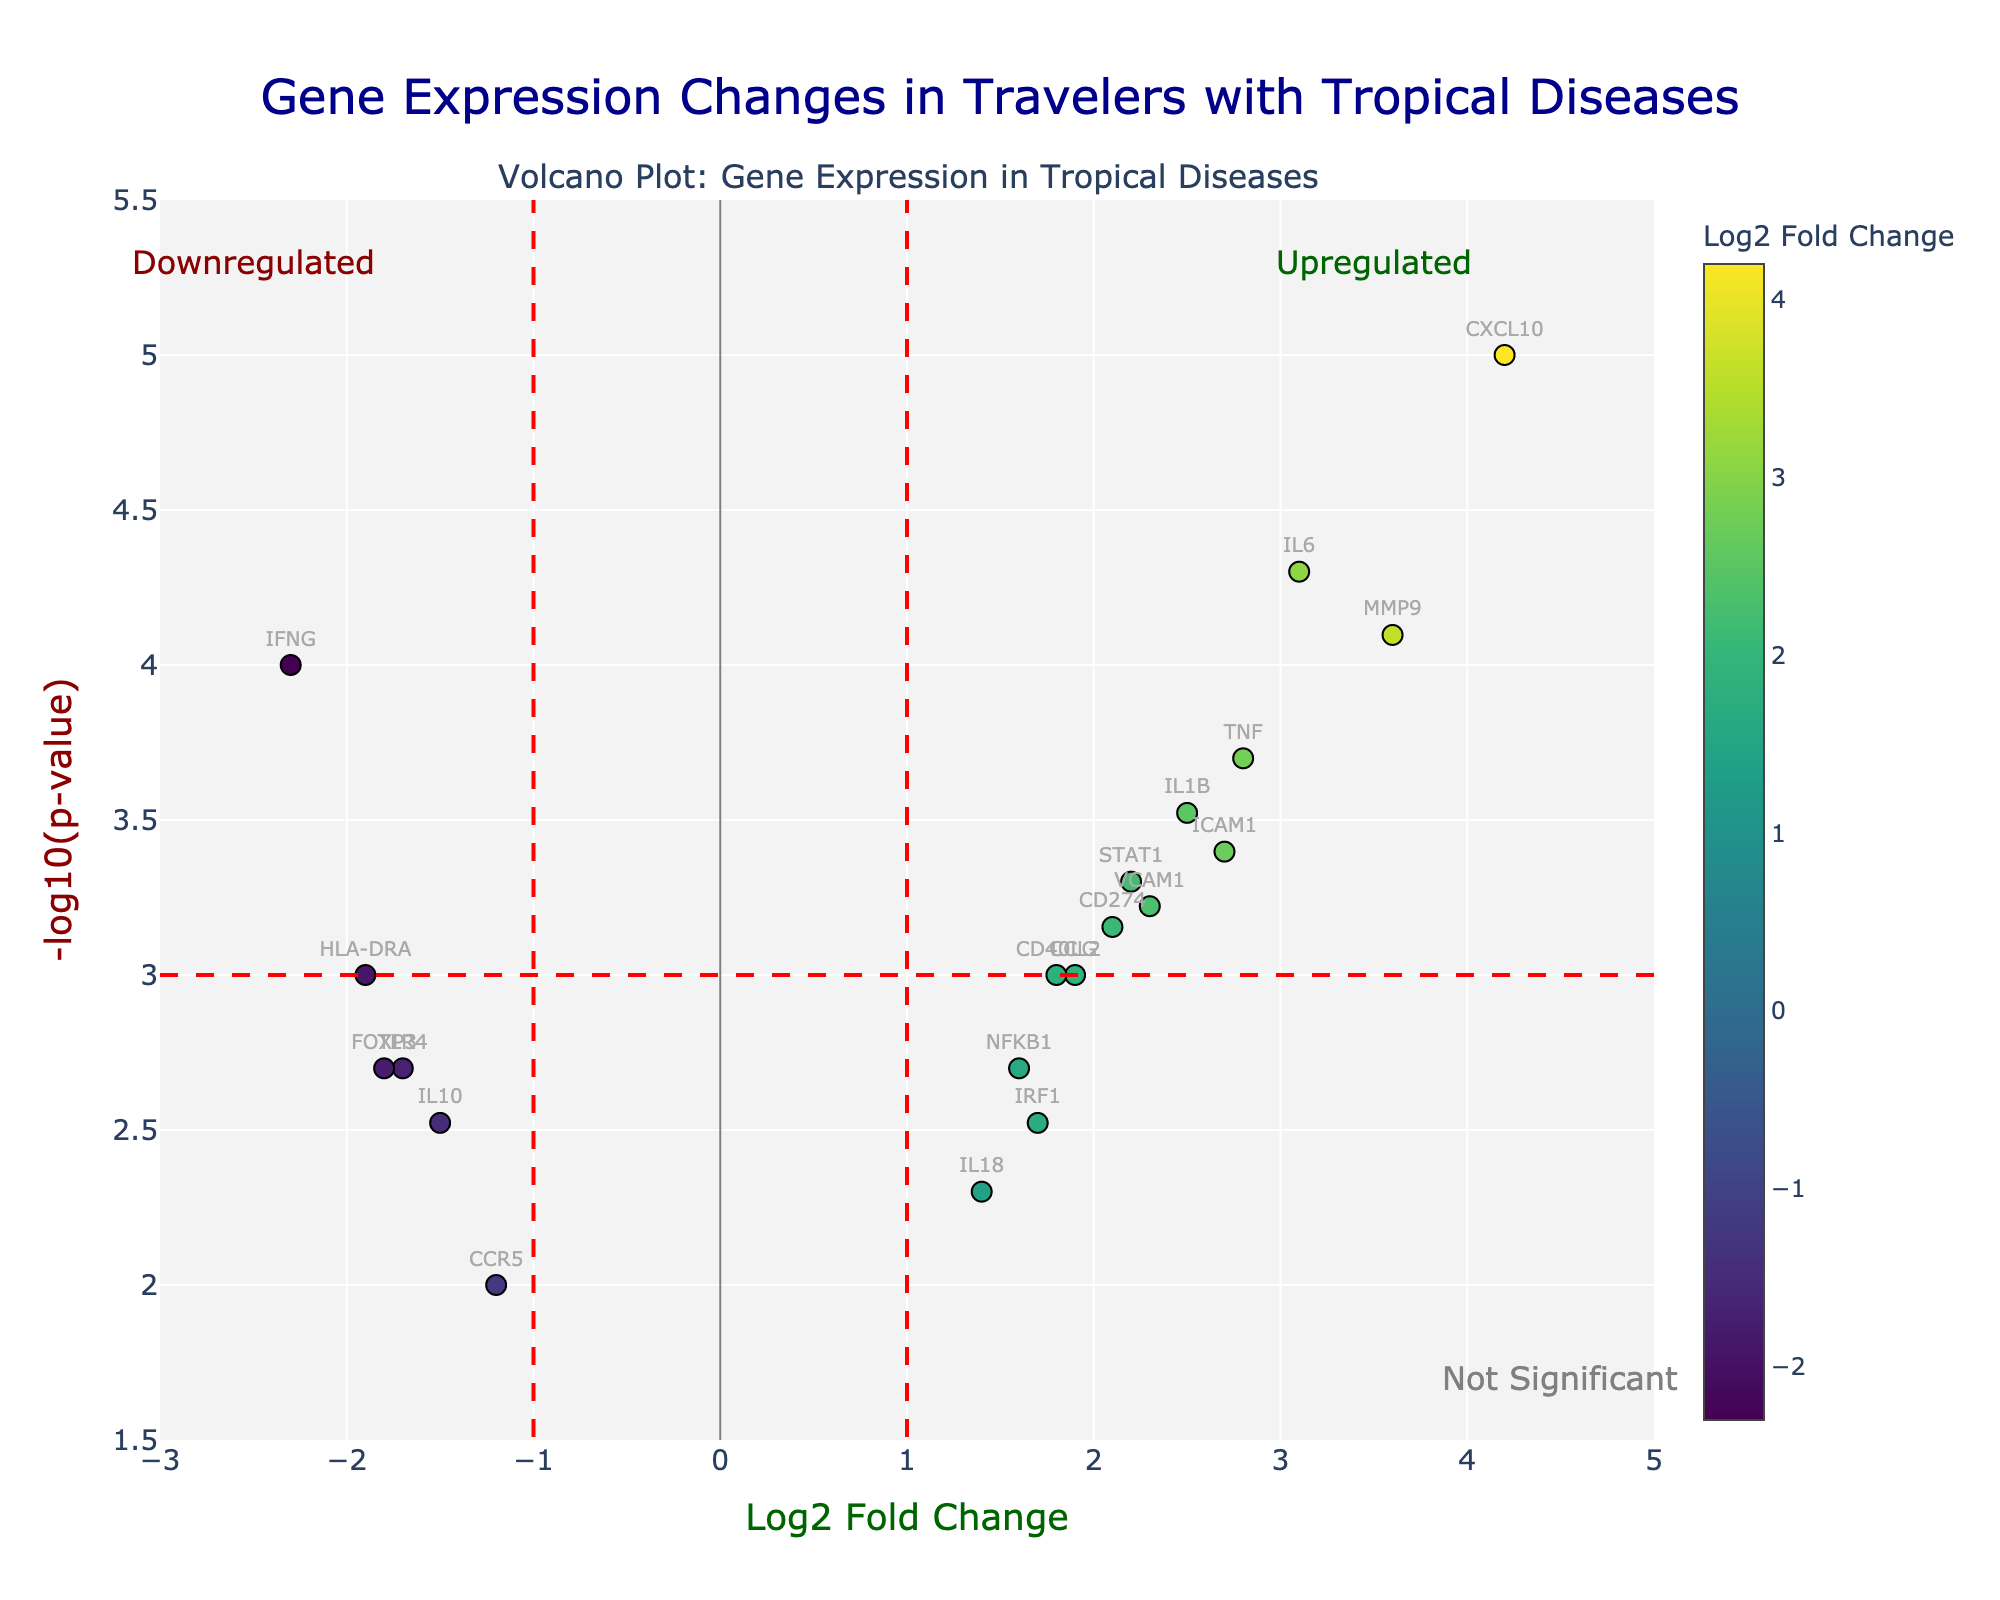What is the title of the figure? The title is located at the top of the figure. It is "Gene Expression Changes in Travelers with Tropical Diseases".
Answer: Gene Expression Changes in Travelers with Tropical Diseases Which gene has the highest -log10(p-value)? The -log10(p-value) is represented on the y-axis. The gene with the highest value in this plot appears to be CXCL10.
Answer: CXCL10 What does the red dashed vertical line indicate on the x-axis? The red dashed vertical lines on the x-axis at -1 and 1 represent thresholds for significant changes in gene expression, indicating the boundaries of significant log2 fold changes.
Answer: Thresholds for significant changes in gene expression Which gene has the highest log2 fold change? By inspecting the x-axis for the highest positive log2FoldChange value, the gene identified is CXCL10.
Answer: CXCL10 How many genes have a -log10(p-value) greater than 3 and a log2 fold change greater than 2? By looking at genes plotted above the horizontal red dashed line (at y=3) and to the right of the red vertical line (x=1), we spot three genes: CXCL10, MMP9, and IL6.
Answer: 3 Are there more upregulated or downregulated genes? Upregulated genes are those with log2 fold change > 1 and downregulated genes with log2 fold change < -1. By counting, we see there are more upregulated genes.
Answer: More upregulated genes What does the color gradient represent in the plot? The color gradient helps to visualize the values of log2 fold change, with different colors representing different magnitudes.
Answer: Log2 fold change Which gene has the lowest log2 fold change? Looking at the farthest negative value on the x-axis, the gene with the lowest log2 fold change is IFNG.
Answer: IFNG What are the fold change values for the gene TLR4 and how does it compare to IL6? The log2 fold change for TLR4 is -1.7 and for IL6 it is 3.1. IL6 is significantly upregulated while TLR4 is downregulated.
Answer: TLR4: -1.7, IL6: 3.1 What does the horizontal red dashed line signify in terms of p-values? The horizontal red dashed line at y=3 signifies the -log10(p-value) threshold, equivalent to a p-value of 0.001. Genes above this line are considered statistically significant.
Answer: -log10(p-value) threshold of 3, corresponding to p-value of 0.001 